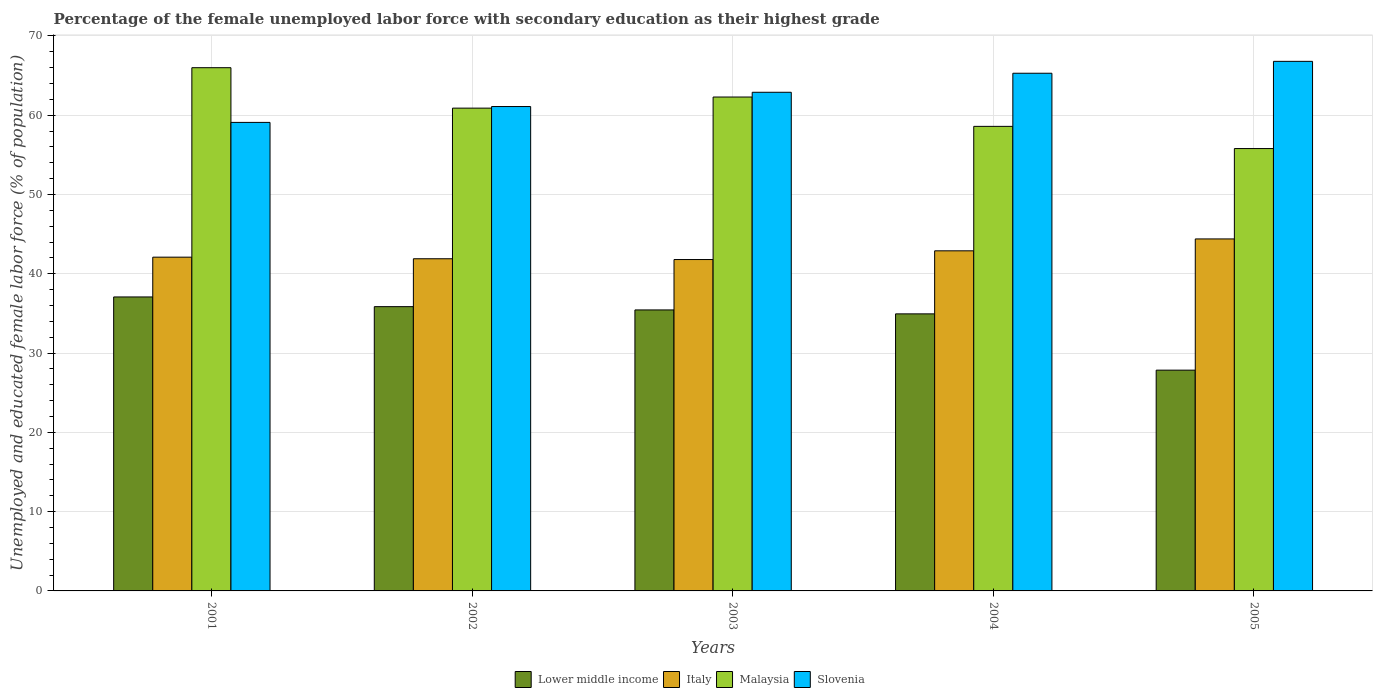How many groups of bars are there?
Keep it short and to the point. 5. Are the number of bars per tick equal to the number of legend labels?
Keep it short and to the point. Yes. How many bars are there on the 3rd tick from the right?
Offer a very short reply. 4. In how many cases, is the number of bars for a given year not equal to the number of legend labels?
Your answer should be very brief. 0. What is the percentage of the unemployed female labor force with secondary education in Italy in 2002?
Your answer should be compact. 41.9. Across all years, what is the maximum percentage of the unemployed female labor force with secondary education in Slovenia?
Make the answer very short. 66.8. Across all years, what is the minimum percentage of the unemployed female labor force with secondary education in Slovenia?
Offer a very short reply. 59.1. What is the total percentage of the unemployed female labor force with secondary education in Slovenia in the graph?
Give a very brief answer. 315.2. What is the difference between the percentage of the unemployed female labor force with secondary education in Slovenia in 2003 and that in 2004?
Give a very brief answer. -2.4. What is the difference between the percentage of the unemployed female labor force with secondary education in Italy in 2005 and the percentage of the unemployed female labor force with secondary education in Slovenia in 2002?
Ensure brevity in your answer.  -16.7. What is the average percentage of the unemployed female labor force with secondary education in Malaysia per year?
Your response must be concise. 60.72. In the year 2004, what is the difference between the percentage of the unemployed female labor force with secondary education in Slovenia and percentage of the unemployed female labor force with secondary education in Malaysia?
Give a very brief answer. 6.7. In how many years, is the percentage of the unemployed female labor force with secondary education in Slovenia greater than 34 %?
Offer a terse response. 5. What is the ratio of the percentage of the unemployed female labor force with secondary education in Lower middle income in 2002 to that in 2004?
Make the answer very short. 1.03. Is the percentage of the unemployed female labor force with secondary education in Malaysia in 2001 less than that in 2003?
Offer a very short reply. No. What is the difference between the highest and the second highest percentage of the unemployed female labor force with secondary education in Lower middle income?
Provide a short and direct response. 1.22. What is the difference between the highest and the lowest percentage of the unemployed female labor force with secondary education in Malaysia?
Keep it short and to the point. 10.2. Is the sum of the percentage of the unemployed female labor force with secondary education in Lower middle income in 2001 and 2005 greater than the maximum percentage of the unemployed female labor force with secondary education in Slovenia across all years?
Ensure brevity in your answer.  No. What does the 2nd bar from the left in 2001 represents?
Offer a very short reply. Italy. What does the 2nd bar from the right in 2003 represents?
Ensure brevity in your answer.  Malaysia. What is the difference between two consecutive major ticks on the Y-axis?
Offer a very short reply. 10. Are the values on the major ticks of Y-axis written in scientific E-notation?
Give a very brief answer. No. Does the graph contain grids?
Provide a short and direct response. Yes. Where does the legend appear in the graph?
Ensure brevity in your answer.  Bottom center. How many legend labels are there?
Your response must be concise. 4. How are the legend labels stacked?
Your response must be concise. Horizontal. What is the title of the graph?
Provide a short and direct response. Percentage of the female unemployed labor force with secondary education as their highest grade. Does "Nigeria" appear as one of the legend labels in the graph?
Offer a terse response. No. What is the label or title of the Y-axis?
Keep it short and to the point. Unemployed and educated female labor force (% of population). What is the Unemployed and educated female labor force (% of population) of Lower middle income in 2001?
Provide a succinct answer. 37.08. What is the Unemployed and educated female labor force (% of population) in Italy in 2001?
Provide a short and direct response. 42.1. What is the Unemployed and educated female labor force (% of population) in Malaysia in 2001?
Offer a terse response. 66. What is the Unemployed and educated female labor force (% of population) of Slovenia in 2001?
Offer a terse response. 59.1. What is the Unemployed and educated female labor force (% of population) of Lower middle income in 2002?
Ensure brevity in your answer.  35.86. What is the Unemployed and educated female labor force (% of population) in Italy in 2002?
Give a very brief answer. 41.9. What is the Unemployed and educated female labor force (% of population) of Malaysia in 2002?
Your answer should be compact. 60.9. What is the Unemployed and educated female labor force (% of population) in Slovenia in 2002?
Give a very brief answer. 61.1. What is the Unemployed and educated female labor force (% of population) in Lower middle income in 2003?
Make the answer very short. 35.45. What is the Unemployed and educated female labor force (% of population) of Italy in 2003?
Give a very brief answer. 41.8. What is the Unemployed and educated female labor force (% of population) of Malaysia in 2003?
Provide a succinct answer. 62.3. What is the Unemployed and educated female labor force (% of population) in Slovenia in 2003?
Your response must be concise. 62.9. What is the Unemployed and educated female labor force (% of population) in Lower middle income in 2004?
Provide a succinct answer. 34.95. What is the Unemployed and educated female labor force (% of population) of Italy in 2004?
Offer a very short reply. 42.9. What is the Unemployed and educated female labor force (% of population) of Malaysia in 2004?
Provide a succinct answer. 58.6. What is the Unemployed and educated female labor force (% of population) in Slovenia in 2004?
Make the answer very short. 65.3. What is the Unemployed and educated female labor force (% of population) of Lower middle income in 2005?
Ensure brevity in your answer.  27.85. What is the Unemployed and educated female labor force (% of population) of Italy in 2005?
Ensure brevity in your answer.  44.4. What is the Unemployed and educated female labor force (% of population) of Malaysia in 2005?
Give a very brief answer. 55.8. What is the Unemployed and educated female labor force (% of population) in Slovenia in 2005?
Ensure brevity in your answer.  66.8. Across all years, what is the maximum Unemployed and educated female labor force (% of population) of Lower middle income?
Offer a very short reply. 37.08. Across all years, what is the maximum Unemployed and educated female labor force (% of population) in Italy?
Give a very brief answer. 44.4. Across all years, what is the maximum Unemployed and educated female labor force (% of population) of Slovenia?
Give a very brief answer. 66.8. Across all years, what is the minimum Unemployed and educated female labor force (% of population) in Lower middle income?
Offer a very short reply. 27.85. Across all years, what is the minimum Unemployed and educated female labor force (% of population) of Italy?
Your answer should be compact. 41.8. Across all years, what is the minimum Unemployed and educated female labor force (% of population) of Malaysia?
Give a very brief answer. 55.8. Across all years, what is the minimum Unemployed and educated female labor force (% of population) in Slovenia?
Make the answer very short. 59.1. What is the total Unemployed and educated female labor force (% of population) of Lower middle income in the graph?
Your response must be concise. 171.18. What is the total Unemployed and educated female labor force (% of population) of Italy in the graph?
Give a very brief answer. 213.1. What is the total Unemployed and educated female labor force (% of population) of Malaysia in the graph?
Offer a very short reply. 303.6. What is the total Unemployed and educated female labor force (% of population) of Slovenia in the graph?
Provide a short and direct response. 315.2. What is the difference between the Unemployed and educated female labor force (% of population) in Lower middle income in 2001 and that in 2002?
Provide a succinct answer. 1.22. What is the difference between the Unemployed and educated female labor force (% of population) in Malaysia in 2001 and that in 2002?
Give a very brief answer. 5.1. What is the difference between the Unemployed and educated female labor force (% of population) of Slovenia in 2001 and that in 2002?
Ensure brevity in your answer.  -2. What is the difference between the Unemployed and educated female labor force (% of population) of Lower middle income in 2001 and that in 2003?
Your answer should be very brief. 1.64. What is the difference between the Unemployed and educated female labor force (% of population) of Malaysia in 2001 and that in 2003?
Ensure brevity in your answer.  3.7. What is the difference between the Unemployed and educated female labor force (% of population) in Slovenia in 2001 and that in 2003?
Keep it short and to the point. -3.8. What is the difference between the Unemployed and educated female labor force (% of population) of Lower middle income in 2001 and that in 2004?
Ensure brevity in your answer.  2.13. What is the difference between the Unemployed and educated female labor force (% of population) of Slovenia in 2001 and that in 2004?
Provide a succinct answer. -6.2. What is the difference between the Unemployed and educated female labor force (% of population) of Lower middle income in 2001 and that in 2005?
Give a very brief answer. 9.23. What is the difference between the Unemployed and educated female labor force (% of population) in Italy in 2001 and that in 2005?
Give a very brief answer. -2.3. What is the difference between the Unemployed and educated female labor force (% of population) of Malaysia in 2001 and that in 2005?
Your answer should be very brief. 10.2. What is the difference between the Unemployed and educated female labor force (% of population) of Slovenia in 2001 and that in 2005?
Offer a terse response. -7.7. What is the difference between the Unemployed and educated female labor force (% of population) of Lower middle income in 2002 and that in 2003?
Your answer should be very brief. 0.41. What is the difference between the Unemployed and educated female labor force (% of population) of Malaysia in 2002 and that in 2003?
Provide a short and direct response. -1.4. What is the difference between the Unemployed and educated female labor force (% of population) in Slovenia in 2002 and that in 2003?
Keep it short and to the point. -1.8. What is the difference between the Unemployed and educated female labor force (% of population) in Lower middle income in 2002 and that in 2004?
Your response must be concise. 0.91. What is the difference between the Unemployed and educated female labor force (% of population) in Malaysia in 2002 and that in 2004?
Give a very brief answer. 2.3. What is the difference between the Unemployed and educated female labor force (% of population) in Slovenia in 2002 and that in 2004?
Provide a succinct answer. -4.2. What is the difference between the Unemployed and educated female labor force (% of population) in Lower middle income in 2002 and that in 2005?
Keep it short and to the point. 8.01. What is the difference between the Unemployed and educated female labor force (% of population) of Italy in 2002 and that in 2005?
Your answer should be very brief. -2.5. What is the difference between the Unemployed and educated female labor force (% of population) in Slovenia in 2002 and that in 2005?
Give a very brief answer. -5.7. What is the difference between the Unemployed and educated female labor force (% of population) of Lower middle income in 2003 and that in 2004?
Provide a short and direct response. 0.5. What is the difference between the Unemployed and educated female labor force (% of population) in Italy in 2003 and that in 2004?
Give a very brief answer. -1.1. What is the difference between the Unemployed and educated female labor force (% of population) of Slovenia in 2003 and that in 2004?
Keep it short and to the point. -2.4. What is the difference between the Unemployed and educated female labor force (% of population) of Lower middle income in 2003 and that in 2005?
Ensure brevity in your answer.  7.6. What is the difference between the Unemployed and educated female labor force (% of population) in Malaysia in 2003 and that in 2005?
Your response must be concise. 6.5. What is the difference between the Unemployed and educated female labor force (% of population) of Lower middle income in 2004 and that in 2005?
Ensure brevity in your answer.  7.1. What is the difference between the Unemployed and educated female labor force (% of population) of Slovenia in 2004 and that in 2005?
Ensure brevity in your answer.  -1.5. What is the difference between the Unemployed and educated female labor force (% of population) of Lower middle income in 2001 and the Unemployed and educated female labor force (% of population) of Italy in 2002?
Keep it short and to the point. -4.82. What is the difference between the Unemployed and educated female labor force (% of population) of Lower middle income in 2001 and the Unemployed and educated female labor force (% of population) of Malaysia in 2002?
Your answer should be compact. -23.82. What is the difference between the Unemployed and educated female labor force (% of population) in Lower middle income in 2001 and the Unemployed and educated female labor force (% of population) in Slovenia in 2002?
Your answer should be very brief. -24.02. What is the difference between the Unemployed and educated female labor force (% of population) in Italy in 2001 and the Unemployed and educated female labor force (% of population) in Malaysia in 2002?
Make the answer very short. -18.8. What is the difference between the Unemployed and educated female labor force (% of population) in Lower middle income in 2001 and the Unemployed and educated female labor force (% of population) in Italy in 2003?
Your response must be concise. -4.72. What is the difference between the Unemployed and educated female labor force (% of population) of Lower middle income in 2001 and the Unemployed and educated female labor force (% of population) of Malaysia in 2003?
Offer a terse response. -25.22. What is the difference between the Unemployed and educated female labor force (% of population) of Lower middle income in 2001 and the Unemployed and educated female labor force (% of population) of Slovenia in 2003?
Give a very brief answer. -25.82. What is the difference between the Unemployed and educated female labor force (% of population) of Italy in 2001 and the Unemployed and educated female labor force (% of population) of Malaysia in 2003?
Ensure brevity in your answer.  -20.2. What is the difference between the Unemployed and educated female labor force (% of population) in Italy in 2001 and the Unemployed and educated female labor force (% of population) in Slovenia in 2003?
Your answer should be very brief. -20.8. What is the difference between the Unemployed and educated female labor force (% of population) of Malaysia in 2001 and the Unemployed and educated female labor force (% of population) of Slovenia in 2003?
Offer a very short reply. 3.1. What is the difference between the Unemployed and educated female labor force (% of population) in Lower middle income in 2001 and the Unemployed and educated female labor force (% of population) in Italy in 2004?
Your response must be concise. -5.82. What is the difference between the Unemployed and educated female labor force (% of population) of Lower middle income in 2001 and the Unemployed and educated female labor force (% of population) of Malaysia in 2004?
Your answer should be compact. -21.52. What is the difference between the Unemployed and educated female labor force (% of population) of Lower middle income in 2001 and the Unemployed and educated female labor force (% of population) of Slovenia in 2004?
Keep it short and to the point. -28.22. What is the difference between the Unemployed and educated female labor force (% of population) in Italy in 2001 and the Unemployed and educated female labor force (% of population) in Malaysia in 2004?
Give a very brief answer. -16.5. What is the difference between the Unemployed and educated female labor force (% of population) of Italy in 2001 and the Unemployed and educated female labor force (% of population) of Slovenia in 2004?
Provide a succinct answer. -23.2. What is the difference between the Unemployed and educated female labor force (% of population) of Malaysia in 2001 and the Unemployed and educated female labor force (% of population) of Slovenia in 2004?
Your answer should be very brief. 0.7. What is the difference between the Unemployed and educated female labor force (% of population) in Lower middle income in 2001 and the Unemployed and educated female labor force (% of population) in Italy in 2005?
Offer a terse response. -7.32. What is the difference between the Unemployed and educated female labor force (% of population) in Lower middle income in 2001 and the Unemployed and educated female labor force (% of population) in Malaysia in 2005?
Provide a succinct answer. -18.72. What is the difference between the Unemployed and educated female labor force (% of population) of Lower middle income in 2001 and the Unemployed and educated female labor force (% of population) of Slovenia in 2005?
Your answer should be compact. -29.72. What is the difference between the Unemployed and educated female labor force (% of population) of Italy in 2001 and the Unemployed and educated female labor force (% of population) of Malaysia in 2005?
Your answer should be compact. -13.7. What is the difference between the Unemployed and educated female labor force (% of population) in Italy in 2001 and the Unemployed and educated female labor force (% of population) in Slovenia in 2005?
Ensure brevity in your answer.  -24.7. What is the difference between the Unemployed and educated female labor force (% of population) of Lower middle income in 2002 and the Unemployed and educated female labor force (% of population) of Italy in 2003?
Make the answer very short. -5.94. What is the difference between the Unemployed and educated female labor force (% of population) in Lower middle income in 2002 and the Unemployed and educated female labor force (% of population) in Malaysia in 2003?
Keep it short and to the point. -26.44. What is the difference between the Unemployed and educated female labor force (% of population) of Lower middle income in 2002 and the Unemployed and educated female labor force (% of population) of Slovenia in 2003?
Keep it short and to the point. -27.04. What is the difference between the Unemployed and educated female labor force (% of population) of Italy in 2002 and the Unemployed and educated female labor force (% of population) of Malaysia in 2003?
Provide a short and direct response. -20.4. What is the difference between the Unemployed and educated female labor force (% of population) of Italy in 2002 and the Unemployed and educated female labor force (% of population) of Slovenia in 2003?
Your answer should be very brief. -21. What is the difference between the Unemployed and educated female labor force (% of population) of Lower middle income in 2002 and the Unemployed and educated female labor force (% of population) of Italy in 2004?
Your answer should be compact. -7.04. What is the difference between the Unemployed and educated female labor force (% of population) of Lower middle income in 2002 and the Unemployed and educated female labor force (% of population) of Malaysia in 2004?
Offer a terse response. -22.74. What is the difference between the Unemployed and educated female labor force (% of population) of Lower middle income in 2002 and the Unemployed and educated female labor force (% of population) of Slovenia in 2004?
Offer a terse response. -29.44. What is the difference between the Unemployed and educated female labor force (% of population) in Italy in 2002 and the Unemployed and educated female labor force (% of population) in Malaysia in 2004?
Make the answer very short. -16.7. What is the difference between the Unemployed and educated female labor force (% of population) of Italy in 2002 and the Unemployed and educated female labor force (% of population) of Slovenia in 2004?
Provide a short and direct response. -23.4. What is the difference between the Unemployed and educated female labor force (% of population) of Malaysia in 2002 and the Unemployed and educated female labor force (% of population) of Slovenia in 2004?
Provide a short and direct response. -4.4. What is the difference between the Unemployed and educated female labor force (% of population) of Lower middle income in 2002 and the Unemployed and educated female labor force (% of population) of Italy in 2005?
Offer a very short reply. -8.54. What is the difference between the Unemployed and educated female labor force (% of population) in Lower middle income in 2002 and the Unemployed and educated female labor force (% of population) in Malaysia in 2005?
Offer a terse response. -19.94. What is the difference between the Unemployed and educated female labor force (% of population) of Lower middle income in 2002 and the Unemployed and educated female labor force (% of population) of Slovenia in 2005?
Your response must be concise. -30.94. What is the difference between the Unemployed and educated female labor force (% of population) of Italy in 2002 and the Unemployed and educated female labor force (% of population) of Malaysia in 2005?
Provide a short and direct response. -13.9. What is the difference between the Unemployed and educated female labor force (% of population) in Italy in 2002 and the Unemployed and educated female labor force (% of population) in Slovenia in 2005?
Make the answer very short. -24.9. What is the difference between the Unemployed and educated female labor force (% of population) of Lower middle income in 2003 and the Unemployed and educated female labor force (% of population) of Italy in 2004?
Make the answer very short. -7.45. What is the difference between the Unemployed and educated female labor force (% of population) of Lower middle income in 2003 and the Unemployed and educated female labor force (% of population) of Malaysia in 2004?
Provide a short and direct response. -23.15. What is the difference between the Unemployed and educated female labor force (% of population) in Lower middle income in 2003 and the Unemployed and educated female labor force (% of population) in Slovenia in 2004?
Your answer should be very brief. -29.85. What is the difference between the Unemployed and educated female labor force (% of population) of Italy in 2003 and the Unemployed and educated female labor force (% of population) of Malaysia in 2004?
Give a very brief answer. -16.8. What is the difference between the Unemployed and educated female labor force (% of population) in Italy in 2003 and the Unemployed and educated female labor force (% of population) in Slovenia in 2004?
Give a very brief answer. -23.5. What is the difference between the Unemployed and educated female labor force (% of population) in Malaysia in 2003 and the Unemployed and educated female labor force (% of population) in Slovenia in 2004?
Give a very brief answer. -3. What is the difference between the Unemployed and educated female labor force (% of population) of Lower middle income in 2003 and the Unemployed and educated female labor force (% of population) of Italy in 2005?
Offer a terse response. -8.95. What is the difference between the Unemployed and educated female labor force (% of population) of Lower middle income in 2003 and the Unemployed and educated female labor force (% of population) of Malaysia in 2005?
Give a very brief answer. -20.35. What is the difference between the Unemployed and educated female labor force (% of population) in Lower middle income in 2003 and the Unemployed and educated female labor force (% of population) in Slovenia in 2005?
Offer a terse response. -31.35. What is the difference between the Unemployed and educated female labor force (% of population) of Italy in 2003 and the Unemployed and educated female labor force (% of population) of Malaysia in 2005?
Make the answer very short. -14. What is the difference between the Unemployed and educated female labor force (% of population) of Italy in 2003 and the Unemployed and educated female labor force (% of population) of Slovenia in 2005?
Ensure brevity in your answer.  -25. What is the difference between the Unemployed and educated female labor force (% of population) of Malaysia in 2003 and the Unemployed and educated female labor force (% of population) of Slovenia in 2005?
Your answer should be compact. -4.5. What is the difference between the Unemployed and educated female labor force (% of population) of Lower middle income in 2004 and the Unemployed and educated female labor force (% of population) of Italy in 2005?
Give a very brief answer. -9.45. What is the difference between the Unemployed and educated female labor force (% of population) in Lower middle income in 2004 and the Unemployed and educated female labor force (% of population) in Malaysia in 2005?
Offer a very short reply. -20.85. What is the difference between the Unemployed and educated female labor force (% of population) in Lower middle income in 2004 and the Unemployed and educated female labor force (% of population) in Slovenia in 2005?
Keep it short and to the point. -31.85. What is the difference between the Unemployed and educated female labor force (% of population) of Italy in 2004 and the Unemployed and educated female labor force (% of population) of Malaysia in 2005?
Your answer should be compact. -12.9. What is the difference between the Unemployed and educated female labor force (% of population) of Italy in 2004 and the Unemployed and educated female labor force (% of population) of Slovenia in 2005?
Keep it short and to the point. -23.9. What is the difference between the Unemployed and educated female labor force (% of population) of Malaysia in 2004 and the Unemployed and educated female labor force (% of population) of Slovenia in 2005?
Your answer should be very brief. -8.2. What is the average Unemployed and educated female labor force (% of population) in Lower middle income per year?
Make the answer very short. 34.24. What is the average Unemployed and educated female labor force (% of population) in Italy per year?
Ensure brevity in your answer.  42.62. What is the average Unemployed and educated female labor force (% of population) of Malaysia per year?
Your answer should be very brief. 60.72. What is the average Unemployed and educated female labor force (% of population) of Slovenia per year?
Your answer should be compact. 63.04. In the year 2001, what is the difference between the Unemployed and educated female labor force (% of population) in Lower middle income and Unemployed and educated female labor force (% of population) in Italy?
Ensure brevity in your answer.  -5.02. In the year 2001, what is the difference between the Unemployed and educated female labor force (% of population) in Lower middle income and Unemployed and educated female labor force (% of population) in Malaysia?
Offer a very short reply. -28.92. In the year 2001, what is the difference between the Unemployed and educated female labor force (% of population) in Lower middle income and Unemployed and educated female labor force (% of population) in Slovenia?
Keep it short and to the point. -22.02. In the year 2001, what is the difference between the Unemployed and educated female labor force (% of population) of Italy and Unemployed and educated female labor force (% of population) of Malaysia?
Give a very brief answer. -23.9. In the year 2001, what is the difference between the Unemployed and educated female labor force (% of population) of Italy and Unemployed and educated female labor force (% of population) of Slovenia?
Keep it short and to the point. -17. In the year 2001, what is the difference between the Unemployed and educated female labor force (% of population) in Malaysia and Unemployed and educated female labor force (% of population) in Slovenia?
Your answer should be compact. 6.9. In the year 2002, what is the difference between the Unemployed and educated female labor force (% of population) in Lower middle income and Unemployed and educated female labor force (% of population) in Italy?
Your answer should be compact. -6.04. In the year 2002, what is the difference between the Unemployed and educated female labor force (% of population) of Lower middle income and Unemployed and educated female labor force (% of population) of Malaysia?
Provide a succinct answer. -25.04. In the year 2002, what is the difference between the Unemployed and educated female labor force (% of population) of Lower middle income and Unemployed and educated female labor force (% of population) of Slovenia?
Offer a very short reply. -25.24. In the year 2002, what is the difference between the Unemployed and educated female labor force (% of population) of Italy and Unemployed and educated female labor force (% of population) of Slovenia?
Your answer should be very brief. -19.2. In the year 2003, what is the difference between the Unemployed and educated female labor force (% of population) of Lower middle income and Unemployed and educated female labor force (% of population) of Italy?
Provide a succinct answer. -6.35. In the year 2003, what is the difference between the Unemployed and educated female labor force (% of population) in Lower middle income and Unemployed and educated female labor force (% of population) in Malaysia?
Offer a terse response. -26.85. In the year 2003, what is the difference between the Unemployed and educated female labor force (% of population) of Lower middle income and Unemployed and educated female labor force (% of population) of Slovenia?
Your answer should be very brief. -27.45. In the year 2003, what is the difference between the Unemployed and educated female labor force (% of population) in Italy and Unemployed and educated female labor force (% of population) in Malaysia?
Give a very brief answer. -20.5. In the year 2003, what is the difference between the Unemployed and educated female labor force (% of population) in Italy and Unemployed and educated female labor force (% of population) in Slovenia?
Ensure brevity in your answer.  -21.1. In the year 2003, what is the difference between the Unemployed and educated female labor force (% of population) of Malaysia and Unemployed and educated female labor force (% of population) of Slovenia?
Your answer should be compact. -0.6. In the year 2004, what is the difference between the Unemployed and educated female labor force (% of population) in Lower middle income and Unemployed and educated female labor force (% of population) in Italy?
Ensure brevity in your answer.  -7.95. In the year 2004, what is the difference between the Unemployed and educated female labor force (% of population) of Lower middle income and Unemployed and educated female labor force (% of population) of Malaysia?
Offer a terse response. -23.65. In the year 2004, what is the difference between the Unemployed and educated female labor force (% of population) of Lower middle income and Unemployed and educated female labor force (% of population) of Slovenia?
Provide a succinct answer. -30.35. In the year 2004, what is the difference between the Unemployed and educated female labor force (% of population) in Italy and Unemployed and educated female labor force (% of population) in Malaysia?
Keep it short and to the point. -15.7. In the year 2004, what is the difference between the Unemployed and educated female labor force (% of population) of Italy and Unemployed and educated female labor force (% of population) of Slovenia?
Make the answer very short. -22.4. In the year 2005, what is the difference between the Unemployed and educated female labor force (% of population) of Lower middle income and Unemployed and educated female labor force (% of population) of Italy?
Your answer should be compact. -16.55. In the year 2005, what is the difference between the Unemployed and educated female labor force (% of population) of Lower middle income and Unemployed and educated female labor force (% of population) of Malaysia?
Provide a short and direct response. -27.95. In the year 2005, what is the difference between the Unemployed and educated female labor force (% of population) in Lower middle income and Unemployed and educated female labor force (% of population) in Slovenia?
Offer a terse response. -38.95. In the year 2005, what is the difference between the Unemployed and educated female labor force (% of population) of Italy and Unemployed and educated female labor force (% of population) of Slovenia?
Your answer should be very brief. -22.4. In the year 2005, what is the difference between the Unemployed and educated female labor force (% of population) of Malaysia and Unemployed and educated female labor force (% of population) of Slovenia?
Your answer should be very brief. -11. What is the ratio of the Unemployed and educated female labor force (% of population) of Lower middle income in 2001 to that in 2002?
Keep it short and to the point. 1.03. What is the ratio of the Unemployed and educated female labor force (% of population) in Malaysia in 2001 to that in 2002?
Your answer should be compact. 1.08. What is the ratio of the Unemployed and educated female labor force (% of population) in Slovenia in 2001 to that in 2002?
Make the answer very short. 0.97. What is the ratio of the Unemployed and educated female labor force (% of population) of Lower middle income in 2001 to that in 2003?
Make the answer very short. 1.05. What is the ratio of the Unemployed and educated female labor force (% of population) of Italy in 2001 to that in 2003?
Make the answer very short. 1.01. What is the ratio of the Unemployed and educated female labor force (% of population) in Malaysia in 2001 to that in 2003?
Your answer should be very brief. 1.06. What is the ratio of the Unemployed and educated female labor force (% of population) in Slovenia in 2001 to that in 2003?
Give a very brief answer. 0.94. What is the ratio of the Unemployed and educated female labor force (% of population) of Lower middle income in 2001 to that in 2004?
Make the answer very short. 1.06. What is the ratio of the Unemployed and educated female labor force (% of population) in Italy in 2001 to that in 2004?
Provide a succinct answer. 0.98. What is the ratio of the Unemployed and educated female labor force (% of population) of Malaysia in 2001 to that in 2004?
Keep it short and to the point. 1.13. What is the ratio of the Unemployed and educated female labor force (% of population) in Slovenia in 2001 to that in 2004?
Provide a succinct answer. 0.91. What is the ratio of the Unemployed and educated female labor force (% of population) of Lower middle income in 2001 to that in 2005?
Your response must be concise. 1.33. What is the ratio of the Unemployed and educated female labor force (% of population) of Italy in 2001 to that in 2005?
Keep it short and to the point. 0.95. What is the ratio of the Unemployed and educated female labor force (% of population) of Malaysia in 2001 to that in 2005?
Keep it short and to the point. 1.18. What is the ratio of the Unemployed and educated female labor force (% of population) in Slovenia in 2001 to that in 2005?
Offer a very short reply. 0.88. What is the ratio of the Unemployed and educated female labor force (% of population) in Lower middle income in 2002 to that in 2003?
Make the answer very short. 1.01. What is the ratio of the Unemployed and educated female labor force (% of population) of Malaysia in 2002 to that in 2003?
Offer a terse response. 0.98. What is the ratio of the Unemployed and educated female labor force (% of population) in Slovenia in 2002 to that in 2003?
Offer a very short reply. 0.97. What is the ratio of the Unemployed and educated female labor force (% of population) in Italy in 2002 to that in 2004?
Keep it short and to the point. 0.98. What is the ratio of the Unemployed and educated female labor force (% of population) in Malaysia in 2002 to that in 2004?
Give a very brief answer. 1.04. What is the ratio of the Unemployed and educated female labor force (% of population) of Slovenia in 2002 to that in 2004?
Make the answer very short. 0.94. What is the ratio of the Unemployed and educated female labor force (% of population) in Lower middle income in 2002 to that in 2005?
Make the answer very short. 1.29. What is the ratio of the Unemployed and educated female labor force (% of population) of Italy in 2002 to that in 2005?
Make the answer very short. 0.94. What is the ratio of the Unemployed and educated female labor force (% of population) of Malaysia in 2002 to that in 2005?
Provide a short and direct response. 1.09. What is the ratio of the Unemployed and educated female labor force (% of population) in Slovenia in 2002 to that in 2005?
Give a very brief answer. 0.91. What is the ratio of the Unemployed and educated female labor force (% of population) in Lower middle income in 2003 to that in 2004?
Your answer should be compact. 1.01. What is the ratio of the Unemployed and educated female labor force (% of population) in Italy in 2003 to that in 2004?
Give a very brief answer. 0.97. What is the ratio of the Unemployed and educated female labor force (% of population) in Malaysia in 2003 to that in 2004?
Provide a succinct answer. 1.06. What is the ratio of the Unemployed and educated female labor force (% of population) of Slovenia in 2003 to that in 2004?
Your answer should be very brief. 0.96. What is the ratio of the Unemployed and educated female labor force (% of population) in Lower middle income in 2003 to that in 2005?
Offer a terse response. 1.27. What is the ratio of the Unemployed and educated female labor force (% of population) in Italy in 2003 to that in 2005?
Give a very brief answer. 0.94. What is the ratio of the Unemployed and educated female labor force (% of population) in Malaysia in 2003 to that in 2005?
Your answer should be very brief. 1.12. What is the ratio of the Unemployed and educated female labor force (% of population) in Slovenia in 2003 to that in 2005?
Provide a short and direct response. 0.94. What is the ratio of the Unemployed and educated female labor force (% of population) in Lower middle income in 2004 to that in 2005?
Provide a succinct answer. 1.25. What is the ratio of the Unemployed and educated female labor force (% of population) of Italy in 2004 to that in 2005?
Keep it short and to the point. 0.97. What is the ratio of the Unemployed and educated female labor force (% of population) of Malaysia in 2004 to that in 2005?
Offer a very short reply. 1.05. What is the ratio of the Unemployed and educated female labor force (% of population) in Slovenia in 2004 to that in 2005?
Keep it short and to the point. 0.98. What is the difference between the highest and the second highest Unemployed and educated female labor force (% of population) of Lower middle income?
Keep it short and to the point. 1.22. What is the difference between the highest and the second highest Unemployed and educated female labor force (% of population) in Malaysia?
Make the answer very short. 3.7. What is the difference between the highest and the lowest Unemployed and educated female labor force (% of population) in Lower middle income?
Your answer should be compact. 9.23. What is the difference between the highest and the lowest Unemployed and educated female labor force (% of population) in Italy?
Your response must be concise. 2.6. What is the difference between the highest and the lowest Unemployed and educated female labor force (% of population) of Malaysia?
Your answer should be very brief. 10.2. 